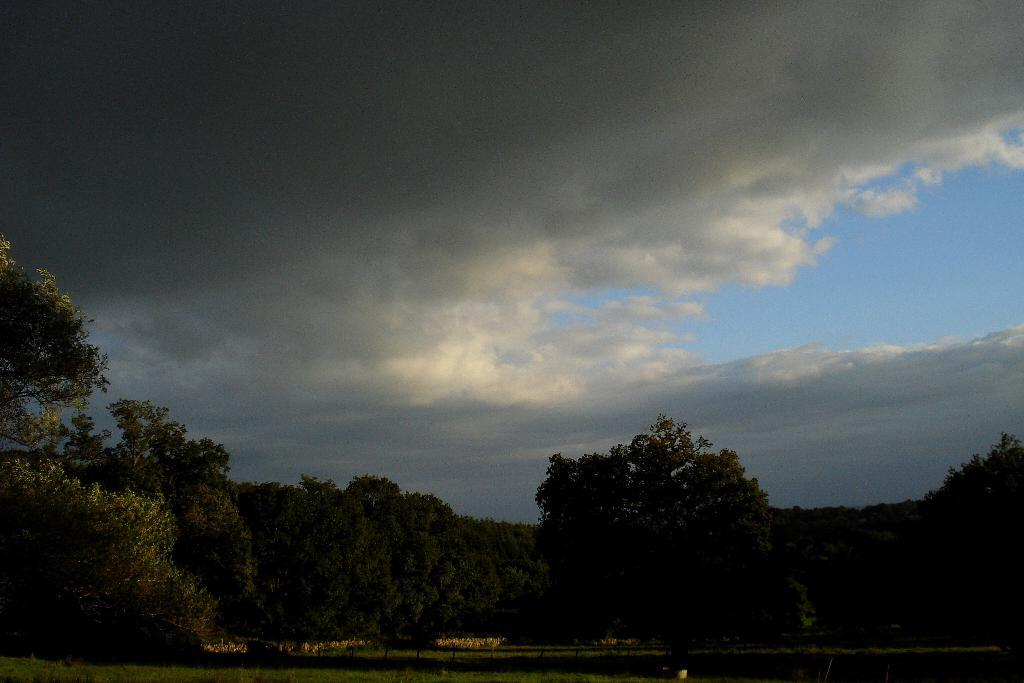What type of vegetation is present at the bottom of the image? There are green trees at the bottom of the image. What is visible in the sky at the top of the image? The sky is cloudy and visible at the top of the image. How does the pollution affect the linen in the image? There is no mention of pollution or linen in the image, so it is not possible to answer that question. 